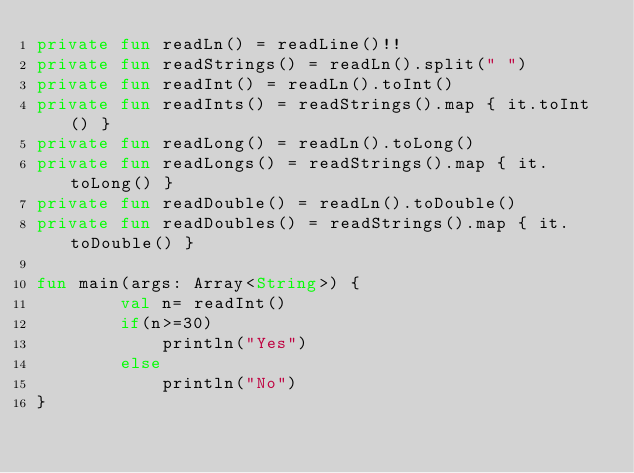<code> <loc_0><loc_0><loc_500><loc_500><_Kotlin_>private fun readLn() = readLine()!!
private fun readStrings() = readLn().split(" ")
private fun readInt() = readLn().toInt()
private fun readInts() = readStrings().map { it.toInt() }
private fun readLong() = readLn().toLong()
private fun readLongs() = readStrings().map { it.toLong() }
private fun readDouble() = readLn().toDouble()
private fun readDoubles() = readStrings().map { it.toDouble() }

fun main(args: Array<String>) {
        val n= readInt()
        if(n>=30)
            println("Yes")
        else
            println("No")
}</code> 